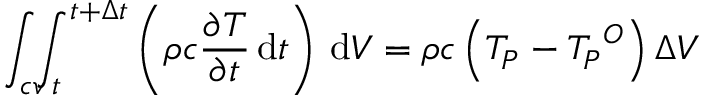<formula> <loc_0><loc_0><loc_500><loc_500>\int _ { c v } \, \int _ { t } ^ { t + \Delta t } \left ( \rho c { \frac { \partial T } { \partial t } } \, d t \right ) \, d V = \rho c \left ( T _ { P } - { T _ { P } } ^ { O } \right ) \Delta V</formula> 